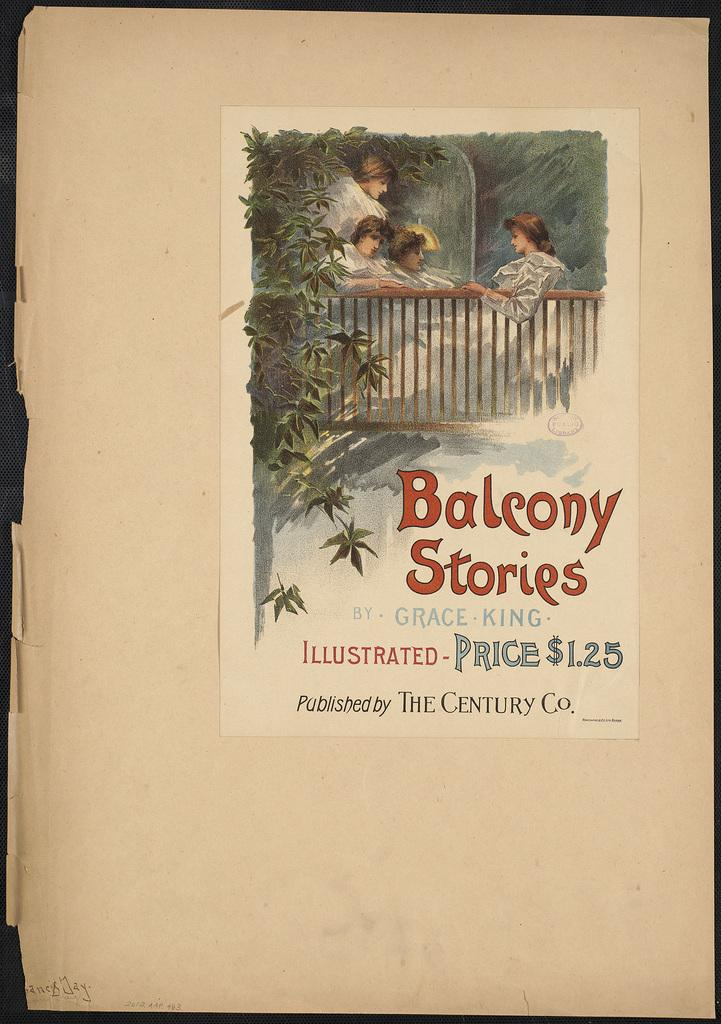<image>
Create a compact narrative representing the image presented. A copy of Balcony stories published by The Century 